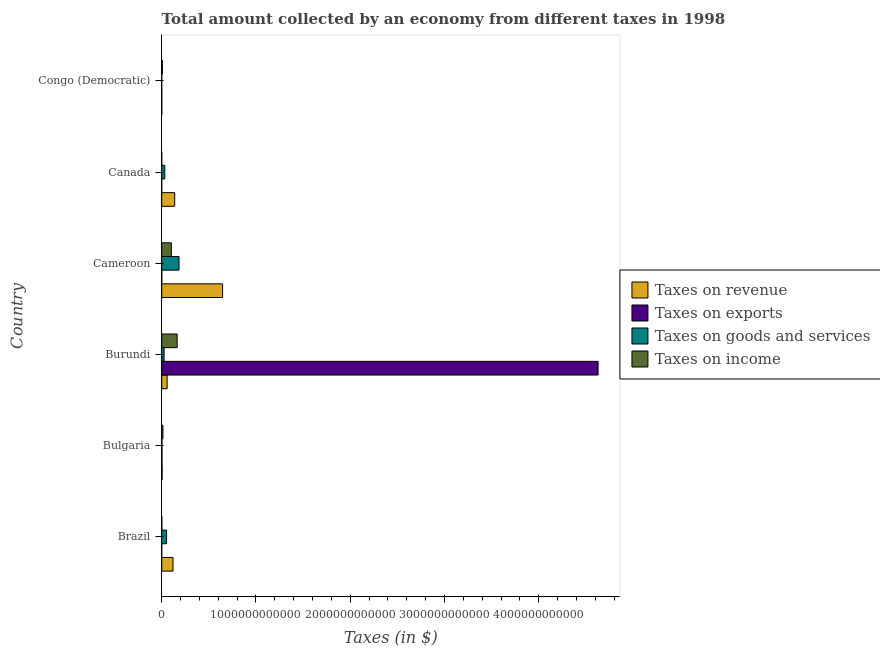How many different coloured bars are there?
Keep it short and to the point. 4. How many groups of bars are there?
Your response must be concise. 6. How many bars are there on the 6th tick from the top?
Keep it short and to the point. 4. How many bars are there on the 1st tick from the bottom?
Keep it short and to the point. 4. What is the label of the 1st group of bars from the top?
Provide a succinct answer. Congo (Democratic). In how many cases, is the number of bars for a given country not equal to the number of legend labels?
Keep it short and to the point. 0. What is the amount collected as tax on exports in Congo (Democratic)?
Your response must be concise. 7.60e+08. Across all countries, what is the maximum amount collected as tax on goods?
Keep it short and to the point. 1.84e+11. Across all countries, what is the minimum amount collected as tax on exports?
Give a very brief answer. 1.00e+06. In which country was the amount collected as tax on goods maximum?
Provide a succinct answer. Cameroon. In which country was the amount collected as tax on exports minimum?
Make the answer very short. Canada. What is the total amount collected as tax on exports in the graph?
Offer a terse response. 4.63e+12. What is the difference between the amount collected as tax on income in Canada and that in Congo (Democratic)?
Offer a terse response. -7.20e+09. What is the difference between the amount collected as tax on revenue in Canada and the amount collected as tax on income in Brazil?
Keep it short and to the point. 1.37e+11. What is the average amount collected as tax on income per country?
Provide a short and direct response. 4.80e+1. What is the difference between the amount collected as tax on goods and amount collected as tax on income in Bulgaria?
Provide a short and direct response. -1.06e+1. What is the ratio of the amount collected as tax on goods in Brazil to that in Bulgaria?
Your response must be concise. 20.47. Is the amount collected as tax on goods in Bulgaria less than that in Burundi?
Provide a short and direct response. Yes. What is the difference between the highest and the second highest amount collected as tax on goods?
Your answer should be very brief. 1.32e+11. What is the difference between the highest and the lowest amount collected as tax on exports?
Keep it short and to the point. 4.63e+12. In how many countries, is the amount collected as tax on goods greater than the average amount collected as tax on goods taken over all countries?
Offer a very short reply. 2. Is it the case that in every country, the sum of the amount collected as tax on exports and amount collected as tax on income is greater than the sum of amount collected as tax on revenue and amount collected as tax on goods?
Keep it short and to the point. No. What does the 4th bar from the top in Burundi represents?
Your answer should be compact. Taxes on revenue. What does the 2nd bar from the bottom in Bulgaria represents?
Make the answer very short. Taxes on exports. Is it the case that in every country, the sum of the amount collected as tax on revenue and amount collected as tax on exports is greater than the amount collected as tax on goods?
Keep it short and to the point. Yes. Are all the bars in the graph horizontal?
Offer a terse response. Yes. What is the difference between two consecutive major ticks on the X-axis?
Your answer should be compact. 1.00e+12. Does the graph contain grids?
Offer a terse response. No. How many legend labels are there?
Make the answer very short. 4. How are the legend labels stacked?
Ensure brevity in your answer.  Vertical. What is the title of the graph?
Provide a succinct answer. Total amount collected by an economy from different taxes in 1998. Does "Italy" appear as one of the legend labels in the graph?
Offer a terse response. No. What is the label or title of the X-axis?
Give a very brief answer. Taxes (in $). What is the Taxes (in $) of Taxes on revenue in Brazil?
Keep it short and to the point. 1.20e+11. What is the Taxes (in $) in Taxes on exports in Brazil?
Your answer should be compact. 5.98e+07. What is the Taxes (in $) in Taxes on goods and services in Brazil?
Offer a very short reply. 5.17e+1. What is the Taxes (in $) of Taxes on income in Brazil?
Keep it short and to the point. 1.10e+09. What is the Taxes (in $) of Taxes on revenue in Bulgaria?
Offer a very short reply. 4.16e+09. What is the Taxes (in $) of Taxes on exports in Bulgaria?
Your answer should be very brief. 2.76e+09. What is the Taxes (in $) of Taxes on goods and services in Bulgaria?
Offer a very short reply. 2.53e+09. What is the Taxes (in $) of Taxes on income in Bulgaria?
Keep it short and to the point. 1.31e+1. What is the Taxes (in $) of Taxes on revenue in Burundi?
Offer a very short reply. 5.74e+1. What is the Taxes (in $) of Taxes on exports in Burundi?
Provide a short and direct response. 4.63e+12. What is the Taxes (in $) of Taxes on goods and services in Burundi?
Keep it short and to the point. 2.53e+1. What is the Taxes (in $) in Taxes on income in Burundi?
Provide a short and direct response. 1.64e+11. What is the Taxes (in $) in Taxes on revenue in Cameroon?
Offer a very short reply. 6.46e+11. What is the Taxes (in $) of Taxes on exports in Cameroon?
Ensure brevity in your answer.  6.23e+08. What is the Taxes (in $) of Taxes on goods and services in Cameroon?
Offer a terse response. 1.84e+11. What is the Taxes (in $) of Taxes on income in Cameroon?
Make the answer very short. 1.02e+11. What is the Taxes (in $) of Taxes on revenue in Canada?
Make the answer very short. 1.38e+11. What is the Taxes (in $) in Taxes on goods and services in Canada?
Your response must be concise. 3.28e+1. What is the Taxes (in $) of Taxes on income in Canada?
Offer a very short reply. 1.77e+08. What is the Taxes (in $) in Taxes on revenue in Congo (Democratic)?
Make the answer very short. 5.34e+08. What is the Taxes (in $) of Taxes on exports in Congo (Democratic)?
Your answer should be compact. 7.60e+08. What is the Taxes (in $) in Taxes on goods and services in Congo (Democratic)?
Offer a terse response. 1.04e+08. What is the Taxes (in $) in Taxes on income in Congo (Democratic)?
Ensure brevity in your answer.  7.38e+09. Across all countries, what is the maximum Taxes (in $) of Taxes on revenue?
Offer a terse response. 6.46e+11. Across all countries, what is the maximum Taxes (in $) of Taxes on exports?
Ensure brevity in your answer.  4.63e+12. Across all countries, what is the maximum Taxes (in $) of Taxes on goods and services?
Your answer should be compact. 1.84e+11. Across all countries, what is the maximum Taxes (in $) in Taxes on income?
Ensure brevity in your answer.  1.64e+11. Across all countries, what is the minimum Taxes (in $) in Taxes on revenue?
Provide a short and direct response. 5.34e+08. Across all countries, what is the minimum Taxes (in $) in Taxes on exports?
Provide a succinct answer. 1.00e+06. Across all countries, what is the minimum Taxes (in $) in Taxes on goods and services?
Provide a succinct answer. 1.04e+08. Across all countries, what is the minimum Taxes (in $) in Taxes on income?
Your answer should be compact. 1.77e+08. What is the total Taxes (in $) in Taxes on revenue in the graph?
Provide a short and direct response. 9.66e+11. What is the total Taxes (in $) in Taxes on exports in the graph?
Provide a short and direct response. 4.63e+12. What is the total Taxes (in $) in Taxes on goods and services in the graph?
Provide a succinct answer. 2.96e+11. What is the total Taxes (in $) in Taxes on income in the graph?
Give a very brief answer. 2.88e+11. What is the difference between the Taxes (in $) in Taxes on revenue in Brazil and that in Bulgaria?
Your answer should be very brief. 1.16e+11. What is the difference between the Taxes (in $) of Taxes on exports in Brazil and that in Bulgaria?
Provide a short and direct response. -2.70e+09. What is the difference between the Taxes (in $) of Taxes on goods and services in Brazil and that in Bulgaria?
Your answer should be compact. 4.92e+1. What is the difference between the Taxes (in $) in Taxes on income in Brazil and that in Bulgaria?
Offer a terse response. -1.20e+1. What is the difference between the Taxes (in $) in Taxes on revenue in Brazil and that in Burundi?
Your response must be concise. 6.24e+1. What is the difference between the Taxes (in $) of Taxes on exports in Brazil and that in Burundi?
Your answer should be very brief. -4.63e+12. What is the difference between the Taxes (in $) in Taxes on goods and services in Brazil and that in Burundi?
Provide a succinct answer. 2.64e+1. What is the difference between the Taxes (in $) in Taxes on income in Brazil and that in Burundi?
Offer a very short reply. -1.63e+11. What is the difference between the Taxes (in $) in Taxes on revenue in Brazil and that in Cameroon?
Your answer should be very brief. -5.26e+11. What is the difference between the Taxes (in $) in Taxes on exports in Brazil and that in Cameroon?
Provide a succinct answer. -5.63e+08. What is the difference between the Taxes (in $) of Taxes on goods and services in Brazil and that in Cameroon?
Your answer should be compact. -1.32e+11. What is the difference between the Taxes (in $) in Taxes on income in Brazil and that in Cameroon?
Offer a terse response. -1.01e+11. What is the difference between the Taxes (in $) in Taxes on revenue in Brazil and that in Canada?
Provide a succinct answer. -1.80e+1. What is the difference between the Taxes (in $) in Taxes on exports in Brazil and that in Canada?
Provide a succinct answer. 5.88e+07. What is the difference between the Taxes (in $) in Taxes on goods and services in Brazil and that in Canada?
Your answer should be compact. 1.89e+1. What is the difference between the Taxes (in $) of Taxes on income in Brazil and that in Canada?
Make the answer very short. 9.28e+08. What is the difference between the Taxes (in $) in Taxes on revenue in Brazil and that in Congo (Democratic)?
Your response must be concise. 1.19e+11. What is the difference between the Taxes (in $) in Taxes on exports in Brazil and that in Congo (Democratic)?
Your answer should be very brief. -7.00e+08. What is the difference between the Taxes (in $) in Taxes on goods and services in Brazil and that in Congo (Democratic)?
Give a very brief answer. 5.16e+1. What is the difference between the Taxes (in $) of Taxes on income in Brazil and that in Congo (Democratic)?
Ensure brevity in your answer.  -6.27e+09. What is the difference between the Taxes (in $) of Taxes on revenue in Bulgaria and that in Burundi?
Provide a short and direct response. -5.33e+1. What is the difference between the Taxes (in $) in Taxes on exports in Bulgaria and that in Burundi?
Ensure brevity in your answer.  -4.63e+12. What is the difference between the Taxes (in $) in Taxes on goods and services in Bulgaria and that in Burundi?
Your response must be concise. -2.28e+1. What is the difference between the Taxes (in $) of Taxes on income in Bulgaria and that in Burundi?
Make the answer very short. -1.51e+11. What is the difference between the Taxes (in $) in Taxes on revenue in Bulgaria and that in Cameroon?
Provide a short and direct response. -6.42e+11. What is the difference between the Taxes (in $) in Taxes on exports in Bulgaria and that in Cameroon?
Your response must be concise. 2.14e+09. What is the difference between the Taxes (in $) of Taxes on goods and services in Bulgaria and that in Cameroon?
Offer a terse response. -1.81e+11. What is the difference between the Taxes (in $) of Taxes on income in Bulgaria and that in Cameroon?
Provide a succinct answer. -8.92e+1. What is the difference between the Taxes (in $) of Taxes on revenue in Bulgaria and that in Canada?
Make the answer very short. -1.34e+11. What is the difference between the Taxes (in $) in Taxes on exports in Bulgaria and that in Canada?
Your response must be concise. 2.76e+09. What is the difference between the Taxes (in $) in Taxes on goods and services in Bulgaria and that in Canada?
Make the answer very short. -3.02e+1. What is the difference between the Taxes (in $) in Taxes on income in Bulgaria and that in Canada?
Offer a terse response. 1.30e+1. What is the difference between the Taxes (in $) in Taxes on revenue in Bulgaria and that in Congo (Democratic)?
Your response must be concise. 3.63e+09. What is the difference between the Taxes (in $) of Taxes on goods and services in Bulgaria and that in Congo (Democratic)?
Make the answer very short. 2.42e+09. What is the difference between the Taxes (in $) in Taxes on income in Bulgaria and that in Congo (Democratic)?
Offer a very short reply. 5.76e+09. What is the difference between the Taxes (in $) in Taxes on revenue in Burundi and that in Cameroon?
Ensure brevity in your answer.  -5.89e+11. What is the difference between the Taxes (in $) of Taxes on exports in Burundi and that in Cameroon?
Your response must be concise. 4.63e+12. What is the difference between the Taxes (in $) of Taxes on goods and services in Burundi and that in Cameroon?
Keep it short and to the point. -1.59e+11. What is the difference between the Taxes (in $) in Taxes on income in Burundi and that in Cameroon?
Offer a terse response. 6.14e+1. What is the difference between the Taxes (in $) of Taxes on revenue in Burundi and that in Canada?
Your answer should be compact. -8.03e+1. What is the difference between the Taxes (in $) in Taxes on exports in Burundi and that in Canada?
Ensure brevity in your answer.  4.63e+12. What is the difference between the Taxes (in $) of Taxes on goods and services in Burundi and that in Canada?
Your answer should be very brief. -7.47e+09. What is the difference between the Taxes (in $) in Taxes on income in Burundi and that in Canada?
Keep it short and to the point. 1.64e+11. What is the difference between the Taxes (in $) in Taxes on revenue in Burundi and that in Congo (Democratic)?
Provide a succinct answer. 5.69e+1. What is the difference between the Taxes (in $) in Taxes on exports in Burundi and that in Congo (Democratic)?
Provide a short and direct response. 4.63e+12. What is the difference between the Taxes (in $) of Taxes on goods and services in Burundi and that in Congo (Democratic)?
Your answer should be very brief. 2.52e+1. What is the difference between the Taxes (in $) in Taxes on income in Burundi and that in Congo (Democratic)?
Your answer should be very brief. 1.56e+11. What is the difference between the Taxes (in $) of Taxes on revenue in Cameroon and that in Canada?
Provide a succinct answer. 5.08e+11. What is the difference between the Taxes (in $) in Taxes on exports in Cameroon and that in Canada?
Your answer should be compact. 6.22e+08. What is the difference between the Taxes (in $) of Taxes on goods and services in Cameroon and that in Canada?
Make the answer very short. 1.51e+11. What is the difference between the Taxes (in $) of Taxes on income in Cameroon and that in Canada?
Provide a short and direct response. 1.02e+11. What is the difference between the Taxes (in $) of Taxes on revenue in Cameroon and that in Congo (Democratic)?
Ensure brevity in your answer.  6.46e+11. What is the difference between the Taxes (in $) of Taxes on exports in Cameroon and that in Congo (Democratic)?
Offer a terse response. -1.37e+08. What is the difference between the Taxes (in $) of Taxes on goods and services in Cameroon and that in Congo (Democratic)?
Offer a terse response. 1.84e+11. What is the difference between the Taxes (in $) in Taxes on income in Cameroon and that in Congo (Democratic)?
Offer a terse response. 9.49e+1. What is the difference between the Taxes (in $) in Taxes on revenue in Canada and that in Congo (Democratic)?
Offer a very short reply. 1.37e+11. What is the difference between the Taxes (in $) of Taxes on exports in Canada and that in Congo (Democratic)?
Make the answer very short. -7.59e+08. What is the difference between the Taxes (in $) of Taxes on goods and services in Canada and that in Congo (Democratic)?
Offer a very short reply. 3.27e+1. What is the difference between the Taxes (in $) of Taxes on income in Canada and that in Congo (Democratic)?
Offer a terse response. -7.20e+09. What is the difference between the Taxes (in $) of Taxes on revenue in Brazil and the Taxes (in $) of Taxes on exports in Bulgaria?
Offer a very short reply. 1.17e+11. What is the difference between the Taxes (in $) of Taxes on revenue in Brazil and the Taxes (in $) of Taxes on goods and services in Bulgaria?
Make the answer very short. 1.17e+11. What is the difference between the Taxes (in $) of Taxes on revenue in Brazil and the Taxes (in $) of Taxes on income in Bulgaria?
Provide a succinct answer. 1.07e+11. What is the difference between the Taxes (in $) of Taxes on exports in Brazil and the Taxes (in $) of Taxes on goods and services in Bulgaria?
Offer a very short reply. -2.47e+09. What is the difference between the Taxes (in $) of Taxes on exports in Brazil and the Taxes (in $) of Taxes on income in Bulgaria?
Provide a short and direct response. -1.31e+1. What is the difference between the Taxes (in $) of Taxes on goods and services in Brazil and the Taxes (in $) of Taxes on income in Bulgaria?
Make the answer very short. 3.86e+1. What is the difference between the Taxes (in $) of Taxes on revenue in Brazil and the Taxes (in $) of Taxes on exports in Burundi?
Your answer should be compact. -4.51e+12. What is the difference between the Taxes (in $) in Taxes on revenue in Brazil and the Taxes (in $) in Taxes on goods and services in Burundi?
Provide a succinct answer. 9.45e+1. What is the difference between the Taxes (in $) in Taxes on revenue in Brazil and the Taxes (in $) in Taxes on income in Burundi?
Give a very brief answer. -4.39e+1. What is the difference between the Taxes (in $) in Taxes on exports in Brazil and the Taxes (in $) in Taxes on goods and services in Burundi?
Your answer should be very brief. -2.52e+1. What is the difference between the Taxes (in $) of Taxes on exports in Brazil and the Taxes (in $) of Taxes on income in Burundi?
Your response must be concise. -1.64e+11. What is the difference between the Taxes (in $) of Taxes on goods and services in Brazil and the Taxes (in $) of Taxes on income in Burundi?
Offer a very short reply. -1.12e+11. What is the difference between the Taxes (in $) of Taxes on revenue in Brazil and the Taxes (in $) of Taxes on exports in Cameroon?
Provide a short and direct response. 1.19e+11. What is the difference between the Taxes (in $) in Taxes on revenue in Brazil and the Taxes (in $) in Taxes on goods and services in Cameroon?
Provide a short and direct response. -6.40e+1. What is the difference between the Taxes (in $) of Taxes on revenue in Brazil and the Taxes (in $) of Taxes on income in Cameroon?
Make the answer very short. 1.75e+1. What is the difference between the Taxes (in $) of Taxes on exports in Brazil and the Taxes (in $) of Taxes on goods and services in Cameroon?
Provide a short and direct response. -1.84e+11. What is the difference between the Taxes (in $) of Taxes on exports in Brazil and the Taxes (in $) of Taxes on income in Cameroon?
Offer a terse response. -1.02e+11. What is the difference between the Taxes (in $) in Taxes on goods and services in Brazil and the Taxes (in $) in Taxes on income in Cameroon?
Provide a short and direct response. -5.06e+1. What is the difference between the Taxes (in $) in Taxes on revenue in Brazil and the Taxes (in $) in Taxes on exports in Canada?
Offer a very short reply. 1.20e+11. What is the difference between the Taxes (in $) in Taxes on revenue in Brazil and the Taxes (in $) in Taxes on goods and services in Canada?
Your answer should be very brief. 8.70e+1. What is the difference between the Taxes (in $) of Taxes on revenue in Brazil and the Taxes (in $) of Taxes on income in Canada?
Keep it short and to the point. 1.20e+11. What is the difference between the Taxes (in $) in Taxes on exports in Brazil and the Taxes (in $) in Taxes on goods and services in Canada?
Keep it short and to the point. -3.27e+1. What is the difference between the Taxes (in $) in Taxes on exports in Brazil and the Taxes (in $) in Taxes on income in Canada?
Give a very brief answer. -1.17e+08. What is the difference between the Taxes (in $) of Taxes on goods and services in Brazil and the Taxes (in $) of Taxes on income in Canada?
Give a very brief answer. 5.15e+1. What is the difference between the Taxes (in $) of Taxes on revenue in Brazil and the Taxes (in $) of Taxes on exports in Congo (Democratic)?
Keep it short and to the point. 1.19e+11. What is the difference between the Taxes (in $) in Taxes on revenue in Brazil and the Taxes (in $) in Taxes on goods and services in Congo (Democratic)?
Your answer should be very brief. 1.20e+11. What is the difference between the Taxes (in $) in Taxes on revenue in Brazil and the Taxes (in $) in Taxes on income in Congo (Democratic)?
Keep it short and to the point. 1.12e+11. What is the difference between the Taxes (in $) in Taxes on exports in Brazil and the Taxes (in $) in Taxes on goods and services in Congo (Democratic)?
Keep it short and to the point. -4.44e+07. What is the difference between the Taxes (in $) of Taxes on exports in Brazil and the Taxes (in $) of Taxes on income in Congo (Democratic)?
Make the answer very short. -7.32e+09. What is the difference between the Taxes (in $) in Taxes on goods and services in Brazil and the Taxes (in $) in Taxes on income in Congo (Democratic)?
Ensure brevity in your answer.  4.43e+1. What is the difference between the Taxes (in $) of Taxes on revenue in Bulgaria and the Taxes (in $) of Taxes on exports in Burundi?
Offer a very short reply. -4.63e+12. What is the difference between the Taxes (in $) of Taxes on revenue in Bulgaria and the Taxes (in $) of Taxes on goods and services in Burundi?
Offer a terse response. -2.11e+1. What is the difference between the Taxes (in $) of Taxes on revenue in Bulgaria and the Taxes (in $) of Taxes on income in Burundi?
Offer a terse response. -1.60e+11. What is the difference between the Taxes (in $) in Taxes on exports in Bulgaria and the Taxes (in $) in Taxes on goods and services in Burundi?
Provide a succinct answer. -2.25e+1. What is the difference between the Taxes (in $) of Taxes on exports in Bulgaria and the Taxes (in $) of Taxes on income in Burundi?
Your response must be concise. -1.61e+11. What is the difference between the Taxes (in $) in Taxes on goods and services in Bulgaria and the Taxes (in $) in Taxes on income in Burundi?
Ensure brevity in your answer.  -1.61e+11. What is the difference between the Taxes (in $) of Taxes on revenue in Bulgaria and the Taxes (in $) of Taxes on exports in Cameroon?
Make the answer very short. 3.54e+09. What is the difference between the Taxes (in $) of Taxes on revenue in Bulgaria and the Taxes (in $) of Taxes on goods and services in Cameroon?
Ensure brevity in your answer.  -1.80e+11. What is the difference between the Taxes (in $) of Taxes on revenue in Bulgaria and the Taxes (in $) of Taxes on income in Cameroon?
Make the answer very short. -9.81e+1. What is the difference between the Taxes (in $) of Taxes on exports in Bulgaria and the Taxes (in $) of Taxes on goods and services in Cameroon?
Make the answer very short. -1.81e+11. What is the difference between the Taxes (in $) in Taxes on exports in Bulgaria and the Taxes (in $) in Taxes on income in Cameroon?
Your response must be concise. -9.95e+1. What is the difference between the Taxes (in $) of Taxes on goods and services in Bulgaria and the Taxes (in $) of Taxes on income in Cameroon?
Give a very brief answer. -9.98e+1. What is the difference between the Taxes (in $) in Taxes on revenue in Bulgaria and the Taxes (in $) in Taxes on exports in Canada?
Offer a very short reply. 4.16e+09. What is the difference between the Taxes (in $) of Taxes on revenue in Bulgaria and the Taxes (in $) of Taxes on goods and services in Canada?
Offer a very short reply. -2.86e+1. What is the difference between the Taxes (in $) of Taxes on revenue in Bulgaria and the Taxes (in $) of Taxes on income in Canada?
Provide a succinct answer. 3.99e+09. What is the difference between the Taxes (in $) in Taxes on exports in Bulgaria and the Taxes (in $) in Taxes on goods and services in Canada?
Your answer should be very brief. -3.00e+1. What is the difference between the Taxes (in $) in Taxes on exports in Bulgaria and the Taxes (in $) in Taxes on income in Canada?
Your answer should be compact. 2.58e+09. What is the difference between the Taxes (in $) of Taxes on goods and services in Bulgaria and the Taxes (in $) of Taxes on income in Canada?
Provide a succinct answer. 2.35e+09. What is the difference between the Taxes (in $) of Taxes on revenue in Bulgaria and the Taxes (in $) of Taxes on exports in Congo (Democratic)?
Offer a very short reply. 3.40e+09. What is the difference between the Taxes (in $) in Taxes on revenue in Bulgaria and the Taxes (in $) in Taxes on goods and services in Congo (Democratic)?
Ensure brevity in your answer.  4.06e+09. What is the difference between the Taxes (in $) of Taxes on revenue in Bulgaria and the Taxes (in $) of Taxes on income in Congo (Democratic)?
Make the answer very short. -3.21e+09. What is the difference between the Taxes (in $) of Taxes on exports in Bulgaria and the Taxes (in $) of Taxes on goods and services in Congo (Democratic)?
Provide a succinct answer. 2.66e+09. What is the difference between the Taxes (in $) of Taxes on exports in Bulgaria and the Taxes (in $) of Taxes on income in Congo (Democratic)?
Provide a short and direct response. -4.62e+09. What is the difference between the Taxes (in $) of Taxes on goods and services in Bulgaria and the Taxes (in $) of Taxes on income in Congo (Democratic)?
Give a very brief answer. -4.85e+09. What is the difference between the Taxes (in $) of Taxes on revenue in Burundi and the Taxes (in $) of Taxes on exports in Cameroon?
Keep it short and to the point. 5.68e+1. What is the difference between the Taxes (in $) in Taxes on revenue in Burundi and the Taxes (in $) in Taxes on goods and services in Cameroon?
Your answer should be very brief. -1.26e+11. What is the difference between the Taxes (in $) of Taxes on revenue in Burundi and the Taxes (in $) of Taxes on income in Cameroon?
Provide a succinct answer. -4.49e+1. What is the difference between the Taxes (in $) in Taxes on exports in Burundi and the Taxes (in $) in Taxes on goods and services in Cameroon?
Offer a terse response. 4.45e+12. What is the difference between the Taxes (in $) of Taxes on exports in Burundi and the Taxes (in $) of Taxes on income in Cameroon?
Offer a very short reply. 4.53e+12. What is the difference between the Taxes (in $) of Taxes on goods and services in Burundi and the Taxes (in $) of Taxes on income in Cameroon?
Provide a succinct answer. -7.70e+1. What is the difference between the Taxes (in $) of Taxes on revenue in Burundi and the Taxes (in $) of Taxes on exports in Canada?
Make the answer very short. 5.74e+1. What is the difference between the Taxes (in $) of Taxes on revenue in Burundi and the Taxes (in $) of Taxes on goods and services in Canada?
Your response must be concise. 2.46e+1. What is the difference between the Taxes (in $) of Taxes on revenue in Burundi and the Taxes (in $) of Taxes on income in Canada?
Make the answer very short. 5.72e+1. What is the difference between the Taxes (in $) of Taxes on exports in Burundi and the Taxes (in $) of Taxes on goods and services in Canada?
Your answer should be compact. 4.60e+12. What is the difference between the Taxes (in $) of Taxes on exports in Burundi and the Taxes (in $) of Taxes on income in Canada?
Give a very brief answer. 4.63e+12. What is the difference between the Taxes (in $) in Taxes on goods and services in Burundi and the Taxes (in $) in Taxes on income in Canada?
Give a very brief answer. 2.51e+1. What is the difference between the Taxes (in $) of Taxes on revenue in Burundi and the Taxes (in $) of Taxes on exports in Congo (Democratic)?
Your answer should be very brief. 5.67e+1. What is the difference between the Taxes (in $) in Taxes on revenue in Burundi and the Taxes (in $) in Taxes on goods and services in Congo (Democratic)?
Provide a succinct answer. 5.73e+1. What is the difference between the Taxes (in $) of Taxes on revenue in Burundi and the Taxes (in $) of Taxes on income in Congo (Democratic)?
Provide a succinct answer. 5.00e+1. What is the difference between the Taxes (in $) in Taxes on exports in Burundi and the Taxes (in $) in Taxes on goods and services in Congo (Democratic)?
Provide a short and direct response. 4.63e+12. What is the difference between the Taxes (in $) in Taxes on exports in Burundi and the Taxes (in $) in Taxes on income in Congo (Democratic)?
Offer a terse response. 4.62e+12. What is the difference between the Taxes (in $) of Taxes on goods and services in Burundi and the Taxes (in $) of Taxes on income in Congo (Democratic)?
Your answer should be compact. 1.79e+1. What is the difference between the Taxes (in $) in Taxes on revenue in Cameroon and the Taxes (in $) in Taxes on exports in Canada?
Provide a succinct answer. 6.46e+11. What is the difference between the Taxes (in $) of Taxes on revenue in Cameroon and the Taxes (in $) of Taxes on goods and services in Canada?
Make the answer very short. 6.13e+11. What is the difference between the Taxes (in $) of Taxes on revenue in Cameroon and the Taxes (in $) of Taxes on income in Canada?
Offer a terse response. 6.46e+11. What is the difference between the Taxes (in $) in Taxes on exports in Cameroon and the Taxes (in $) in Taxes on goods and services in Canada?
Provide a succinct answer. -3.22e+1. What is the difference between the Taxes (in $) of Taxes on exports in Cameroon and the Taxes (in $) of Taxes on income in Canada?
Your answer should be very brief. 4.46e+08. What is the difference between the Taxes (in $) of Taxes on goods and services in Cameroon and the Taxes (in $) of Taxes on income in Canada?
Your response must be concise. 1.84e+11. What is the difference between the Taxes (in $) in Taxes on revenue in Cameroon and the Taxes (in $) in Taxes on exports in Congo (Democratic)?
Provide a succinct answer. 6.45e+11. What is the difference between the Taxes (in $) in Taxes on revenue in Cameroon and the Taxes (in $) in Taxes on goods and services in Congo (Democratic)?
Ensure brevity in your answer.  6.46e+11. What is the difference between the Taxes (in $) in Taxes on revenue in Cameroon and the Taxes (in $) in Taxes on income in Congo (Democratic)?
Your answer should be very brief. 6.39e+11. What is the difference between the Taxes (in $) of Taxes on exports in Cameroon and the Taxes (in $) of Taxes on goods and services in Congo (Democratic)?
Make the answer very short. 5.19e+08. What is the difference between the Taxes (in $) of Taxes on exports in Cameroon and the Taxes (in $) of Taxes on income in Congo (Democratic)?
Give a very brief answer. -6.75e+09. What is the difference between the Taxes (in $) of Taxes on goods and services in Cameroon and the Taxes (in $) of Taxes on income in Congo (Democratic)?
Provide a short and direct response. 1.76e+11. What is the difference between the Taxes (in $) of Taxes on revenue in Canada and the Taxes (in $) of Taxes on exports in Congo (Democratic)?
Give a very brief answer. 1.37e+11. What is the difference between the Taxes (in $) in Taxes on revenue in Canada and the Taxes (in $) in Taxes on goods and services in Congo (Democratic)?
Offer a very short reply. 1.38e+11. What is the difference between the Taxes (in $) in Taxes on revenue in Canada and the Taxes (in $) in Taxes on income in Congo (Democratic)?
Ensure brevity in your answer.  1.30e+11. What is the difference between the Taxes (in $) in Taxes on exports in Canada and the Taxes (in $) in Taxes on goods and services in Congo (Democratic)?
Your response must be concise. -1.03e+08. What is the difference between the Taxes (in $) in Taxes on exports in Canada and the Taxes (in $) in Taxes on income in Congo (Democratic)?
Give a very brief answer. -7.38e+09. What is the difference between the Taxes (in $) of Taxes on goods and services in Canada and the Taxes (in $) of Taxes on income in Congo (Democratic)?
Your answer should be compact. 2.54e+1. What is the average Taxes (in $) of Taxes on revenue per country?
Offer a very short reply. 1.61e+11. What is the average Taxes (in $) of Taxes on exports per country?
Provide a short and direct response. 7.72e+11. What is the average Taxes (in $) of Taxes on goods and services per country?
Offer a terse response. 4.94e+1. What is the average Taxes (in $) in Taxes on income per country?
Offer a very short reply. 4.80e+1. What is the difference between the Taxes (in $) in Taxes on revenue and Taxes (in $) in Taxes on exports in Brazil?
Your answer should be compact. 1.20e+11. What is the difference between the Taxes (in $) of Taxes on revenue and Taxes (in $) of Taxes on goods and services in Brazil?
Offer a very short reply. 6.81e+1. What is the difference between the Taxes (in $) in Taxes on revenue and Taxes (in $) in Taxes on income in Brazil?
Your answer should be compact. 1.19e+11. What is the difference between the Taxes (in $) of Taxes on exports and Taxes (in $) of Taxes on goods and services in Brazil?
Your answer should be compact. -5.16e+1. What is the difference between the Taxes (in $) in Taxes on exports and Taxes (in $) in Taxes on income in Brazil?
Provide a succinct answer. -1.04e+09. What is the difference between the Taxes (in $) in Taxes on goods and services and Taxes (in $) in Taxes on income in Brazil?
Your response must be concise. 5.06e+1. What is the difference between the Taxes (in $) of Taxes on revenue and Taxes (in $) of Taxes on exports in Bulgaria?
Your response must be concise. 1.40e+09. What is the difference between the Taxes (in $) in Taxes on revenue and Taxes (in $) in Taxes on goods and services in Bulgaria?
Offer a terse response. 1.64e+09. What is the difference between the Taxes (in $) in Taxes on revenue and Taxes (in $) in Taxes on income in Bulgaria?
Provide a short and direct response. -8.97e+09. What is the difference between the Taxes (in $) of Taxes on exports and Taxes (in $) of Taxes on goods and services in Bulgaria?
Provide a succinct answer. 2.34e+08. What is the difference between the Taxes (in $) in Taxes on exports and Taxes (in $) in Taxes on income in Bulgaria?
Offer a terse response. -1.04e+1. What is the difference between the Taxes (in $) of Taxes on goods and services and Taxes (in $) of Taxes on income in Bulgaria?
Provide a succinct answer. -1.06e+1. What is the difference between the Taxes (in $) in Taxes on revenue and Taxes (in $) in Taxes on exports in Burundi?
Offer a terse response. -4.57e+12. What is the difference between the Taxes (in $) in Taxes on revenue and Taxes (in $) in Taxes on goods and services in Burundi?
Provide a succinct answer. 3.21e+1. What is the difference between the Taxes (in $) in Taxes on revenue and Taxes (in $) in Taxes on income in Burundi?
Give a very brief answer. -1.06e+11. What is the difference between the Taxes (in $) in Taxes on exports and Taxes (in $) in Taxes on goods and services in Burundi?
Your response must be concise. 4.60e+12. What is the difference between the Taxes (in $) in Taxes on exports and Taxes (in $) in Taxes on income in Burundi?
Offer a terse response. 4.47e+12. What is the difference between the Taxes (in $) in Taxes on goods and services and Taxes (in $) in Taxes on income in Burundi?
Provide a succinct answer. -1.38e+11. What is the difference between the Taxes (in $) in Taxes on revenue and Taxes (in $) in Taxes on exports in Cameroon?
Your answer should be very brief. 6.46e+11. What is the difference between the Taxes (in $) in Taxes on revenue and Taxes (in $) in Taxes on goods and services in Cameroon?
Your answer should be very brief. 4.62e+11. What is the difference between the Taxes (in $) of Taxes on revenue and Taxes (in $) of Taxes on income in Cameroon?
Ensure brevity in your answer.  5.44e+11. What is the difference between the Taxes (in $) of Taxes on exports and Taxes (in $) of Taxes on goods and services in Cameroon?
Your answer should be compact. -1.83e+11. What is the difference between the Taxes (in $) of Taxes on exports and Taxes (in $) of Taxes on income in Cameroon?
Your answer should be compact. -1.02e+11. What is the difference between the Taxes (in $) of Taxes on goods and services and Taxes (in $) of Taxes on income in Cameroon?
Ensure brevity in your answer.  8.15e+1. What is the difference between the Taxes (in $) of Taxes on revenue and Taxes (in $) of Taxes on exports in Canada?
Ensure brevity in your answer.  1.38e+11. What is the difference between the Taxes (in $) in Taxes on revenue and Taxes (in $) in Taxes on goods and services in Canada?
Your answer should be compact. 1.05e+11. What is the difference between the Taxes (in $) in Taxes on revenue and Taxes (in $) in Taxes on income in Canada?
Provide a succinct answer. 1.38e+11. What is the difference between the Taxes (in $) in Taxes on exports and Taxes (in $) in Taxes on goods and services in Canada?
Ensure brevity in your answer.  -3.28e+1. What is the difference between the Taxes (in $) of Taxes on exports and Taxes (in $) of Taxes on income in Canada?
Your answer should be very brief. -1.76e+08. What is the difference between the Taxes (in $) in Taxes on goods and services and Taxes (in $) in Taxes on income in Canada?
Provide a short and direct response. 3.26e+1. What is the difference between the Taxes (in $) of Taxes on revenue and Taxes (in $) of Taxes on exports in Congo (Democratic)?
Your answer should be very brief. -2.26e+08. What is the difference between the Taxes (in $) of Taxes on revenue and Taxes (in $) of Taxes on goods and services in Congo (Democratic)?
Make the answer very short. 4.30e+08. What is the difference between the Taxes (in $) of Taxes on revenue and Taxes (in $) of Taxes on income in Congo (Democratic)?
Offer a terse response. -6.84e+09. What is the difference between the Taxes (in $) in Taxes on exports and Taxes (in $) in Taxes on goods and services in Congo (Democratic)?
Provide a short and direct response. 6.56e+08. What is the difference between the Taxes (in $) of Taxes on exports and Taxes (in $) of Taxes on income in Congo (Democratic)?
Provide a succinct answer. -6.62e+09. What is the difference between the Taxes (in $) in Taxes on goods and services and Taxes (in $) in Taxes on income in Congo (Democratic)?
Give a very brief answer. -7.27e+09. What is the ratio of the Taxes (in $) of Taxes on revenue in Brazil to that in Bulgaria?
Offer a very short reply. 28.77. What is the ratio of the Taxes (in $) of Taxes on exports in Brazil to that in Bulgaria?
Your answer should be very brief. 0.02. What is the ratio of the Taxes (in $) in Taxes on goods and services in Brazil to that in Bulgaria?
Your response must be concise. 20.47. What is the ratio of the Taxes (in $) of Taxes on income in Brazil to that in Bulgaria?
Give a very brief answer. 0.08. What is the ratio of the Taxes (in $) in Taxes on revenue in Brazil to that in Burundi?
Provide a succinct answer. 2.09. What is the ratio of the Taxes (in $) in Taxes on exports in Brazil to that in Burundi?
Give a very brief answer. 0. What is the ratio of the Taxes (in $) of Taxes on goods and services in Brazil to that in Burundi?
Make the answer very short. 2.04. What is the ratio of the Taxes (in $) of Taxes on income in Brazil to that in Burundi?
Your response must be concise. 0.01. What is the ratio of the Taxes (in $) of Taxes on revenue in Brazil to that in Cameroon?
Your answer should be very brief. 0.19. What is the ratio of the Taxes (in $) of Taxes on exports in Brazil to that in Cameroon?
Your answer should be compact. 0.1. What is the ratio of the Taxes (in $) in Taxes on goods and services in Brazil to that in Cameroon?
Make the answer very short. 0.28. What is the ratio of the Taxes (in $) in Taxes on income in Brazil to that in Cameroon?
Offer a terse response. 0.01. What is the ratio of the Taxes (in $) in Taxes on revenue in Brazil to that in Canada?
Give a very brief answer. 0.87. What is the ratio of the Taxes (in $) of Taxes on exports in Brazil to that in Canada?
Ensure brevity in your answer.  59.8. What is the ratio of the Taxes (in $) in Taxes on goods and services in Brazil to that in Canada?
Make the answer very short. 1.58. What is the ratio of the Taxes (in $) of Taxes on income in Brazil to that in Canada?
Offer a very short reply. 6.25. What is the ratio of the Taxes (in $) in Taxes on revenue in Brazil to that in Congo (Democratic)?
Offer a very short reply. 224.17. What is the ratio of the Taxes (in $) in Taxes on exports in Brazil to that in Congo (Democratic)?
Provide a succinct answer. 0.08. What is the ratio of the Taxes (in $) in Taxes on goods and services in Brazil to that in Congo (Democratic)?
Offer a terse response. 496.1. What is the ratio of the Taxes (in $) in Taxes on income in Brazil to that in Congo (Democratic)?
Offer a terse response. 0.15. What is the ratio of the Taxes (in $) in Taxes on revenue in Bulgaria to that in Burundi?
Make the answer very short. 0.07. What is the ratio of the Taxes (in $) of Taxes on exports in Bulgaria to that in Burundi?
Keep it short and to the point. 0. What is the ratio of the Taxes (in $) in Taxes on goods and services in Bulgaria to that in Burundi?
Provide a succinct answer. 0.1. What is the ratio of the Taxes (in $) in Taxes on income in Bulgaria to that in Burundi?
Offer a very short reply. 0.08. What is the ratio of the Taxes (in $) in Taxes on revenue in Bulgaria to that in Cameroon?
Provide a short and direct response. 0.01. What is the ratio of the Taxes (in $) of Taxes on exports in Bulgaria to that in Cameroon?
Offer a terse response. 4.43. What is the ratio of the Taxes (in $) of Taxes on goods and services in Bulgaria to that in Cameroon?
Keep it short and to the point. 0.01. What is the ratio of the Taxes (in $) of Taxes on income in Bulgaria to that in Cameroon?
Your response must be concise. 0.13. What is the ratio of the Taxes (in $) of Taxes on revenue in Bulgaria to that in Canada?
Provide a succinct answer. 0.03. What is the ratio of the Taxes (in $) of Taxes on exports in Bulgaria to that in Canada?
Provide a short and direct response. 2760. What is the ratio of the Taxes (in $) in Taxes on goods and services in Bulgaria to that in Canada?
Offer a terse response. 0.08. What is the ratio of the Taxes (in $) in Taxes on income in Bulgaria to that in Canada?
Offer a terse response. 74.35. What is the ratio of the Taxes (in $) of Taxes on revenue in Bulgaria to that in Congo (Democratic)?
Provide a short and direct response. 7.79. What is the ratio of the Taxes (in $) in Taxes on exports in Bulgaria to that in Congo (Democratic)?
Offer a very short reply. 3.63. What is the ratio of the Taxes (in $) in Taxes on goods and services in Bulgaria to that in Congo (Democratic)?
Offer a terse response. 24.24. What is the ratio of the Taxes (in $) of Taxes on income in Bulgaria to that in Congo (Democratic)?
Make the answer very short. 1.78. What is the ratio of the Taxes (in $) of Taxes on revenue in Burundi to that in Cameroon?
Offer a very short reply. 0.09. What is the ratio of the Taxes (in $) in Taxes on exports in Burundi to that in Cameroon?
Provide a short and direct response. 7431.78. What is the ratio of the Taxes (in $) in Taxes on goods and services in Burundi to that in Cameroon?
Your response must be concise. 0.14. What is the ratio of the Taxes (in $) in Taxes on income in Burundi to that in Cameroon?
Offer a very short reply. 1.6. What is the ratio of the Taxes (in $) of Taxes on revenue in Burundi to that in Canada?
Your response must be concise. 0.42. What is the ratio of the Taxes (in $) in Taxes on exports in Burundi to that in Canada?
Offer a terse response. 4.63e+06. What is the ratio of the Taxes (in $) in Taxes on goods and services in Burundi to that in Canada?
Your answer should be compact. 0.77. What is the ratio of the Taxes (in $) in Taxes on income in Burundi to that in Canada?
Keep it short and to the point. 926.28. What is the ratio of the Taxes (in $) of Taxes on revenue in Burundi to that in Congo (Democratic)?
Offer a terse response. 107.44. What is the ratio of the Taxes (in $) in Taxes on exports in Burundi to that in Congo (Democratic)?
Keep it short and to the point. 6092.11. What is the ratio of the Taxes (in $) of Taxes on goods and services in Burundi to that in Congo (Democratic)?
Offer a very short reply. 242.8. What is the ratio of the Taxes (in $) in Taxes on income in Burundi to that in Congo (Democratic)?
Provide a short and direct response. 22.19. What is the ratio of the Taxes (in $) of Taxes on revenue in Cameroon to that in Canada?
Make the answer very short. 4.69. What is the ratio of the Taxes (in $) in Taxes on exports in Cameroon to that in Canada?
Ensure brevity in your answer.  623. What is the ratio of the Taxes (in $) of Taxes on goods and services in Cameroon to that in Canada?
Offer a terse response. 5.61. What is the ratio of the Taxes (in $) of Taxes on income in Cameroon to that in Canada?
Your answer should be very brief. 578.89. What is the ratio of the Taxes (in $) in Taxes on revenue in Cameroon to that in Congo (Democratic)?
Make the answer very short. 1209.09. What is the ratio of the Taxes (in $) in Taxes on exports in Cameroon to that in Congo (Democratic)?
Provide a succinct answer. 0.82. What is the ratio of the Taxes (in $) in Taxes on goods and services in Cameroon to that in Congo (Democratic)?
Give a very brief answer. 1763.77. What is the ratio of the Taxes (in $) of Taxes on income in Cameroon to that in Congo (Democratic)?
Provide a succinct answer. 13.87. What is the ratio of the Taxes (in $) in Taxes on revenue in Canada to that in Congo (Democratic)?
Offer a terse response. 257.76. What is the ratio of the Taxes (in $) in Taxes on exports in Canada to that in Congo (Democratic)?
Offer a terse response. 0. What is the ratio of the Taxes (in $) in Taxes on goods and services in Canada to that in Congo (Democratic)?
Your response must be concise. 314.49. What is the ratio of the Taxes (in $) in Taxes on income in Canada to that in Congo (Democratic)?
Make the answer very short. 0.02. What is the difference between the highest and the second highest Taxes (in $) in Taxes on revenue?
Offer a terse response. 5.08e+11. What is the difference between the highest and the second highest Taxes (in $) in Taxes on exports?
Keep it short and to the point. 4.63e+12. What is the difference between the highest and the second highest Taxes (in $) of Taxes on goods and services?
Your answer should be compact. 1.32e+11. What is the difference between the highest and the second highest Taxes (in $) of Taxes on income?
Offer a terse response. 6.14e+1. What is the difference between the highest and the lowest Taxes (in $) in Taxes on revenue?
Offer a terse response. 6.46e+11. What is the difference between the highest and the lowest Taxes (in $) in Taxes on exports?
Provide a short and direct response. 4.63e+12. What is the difference between the highest and the lowest Taxes (in $) of Taxes on goods and services?
Keep it short and to the point. 1.84e+11. What is the difference between the highest and the lowest Taxes (in $) in Taxes on income?
Make the answer very short. 1.64e+11. 